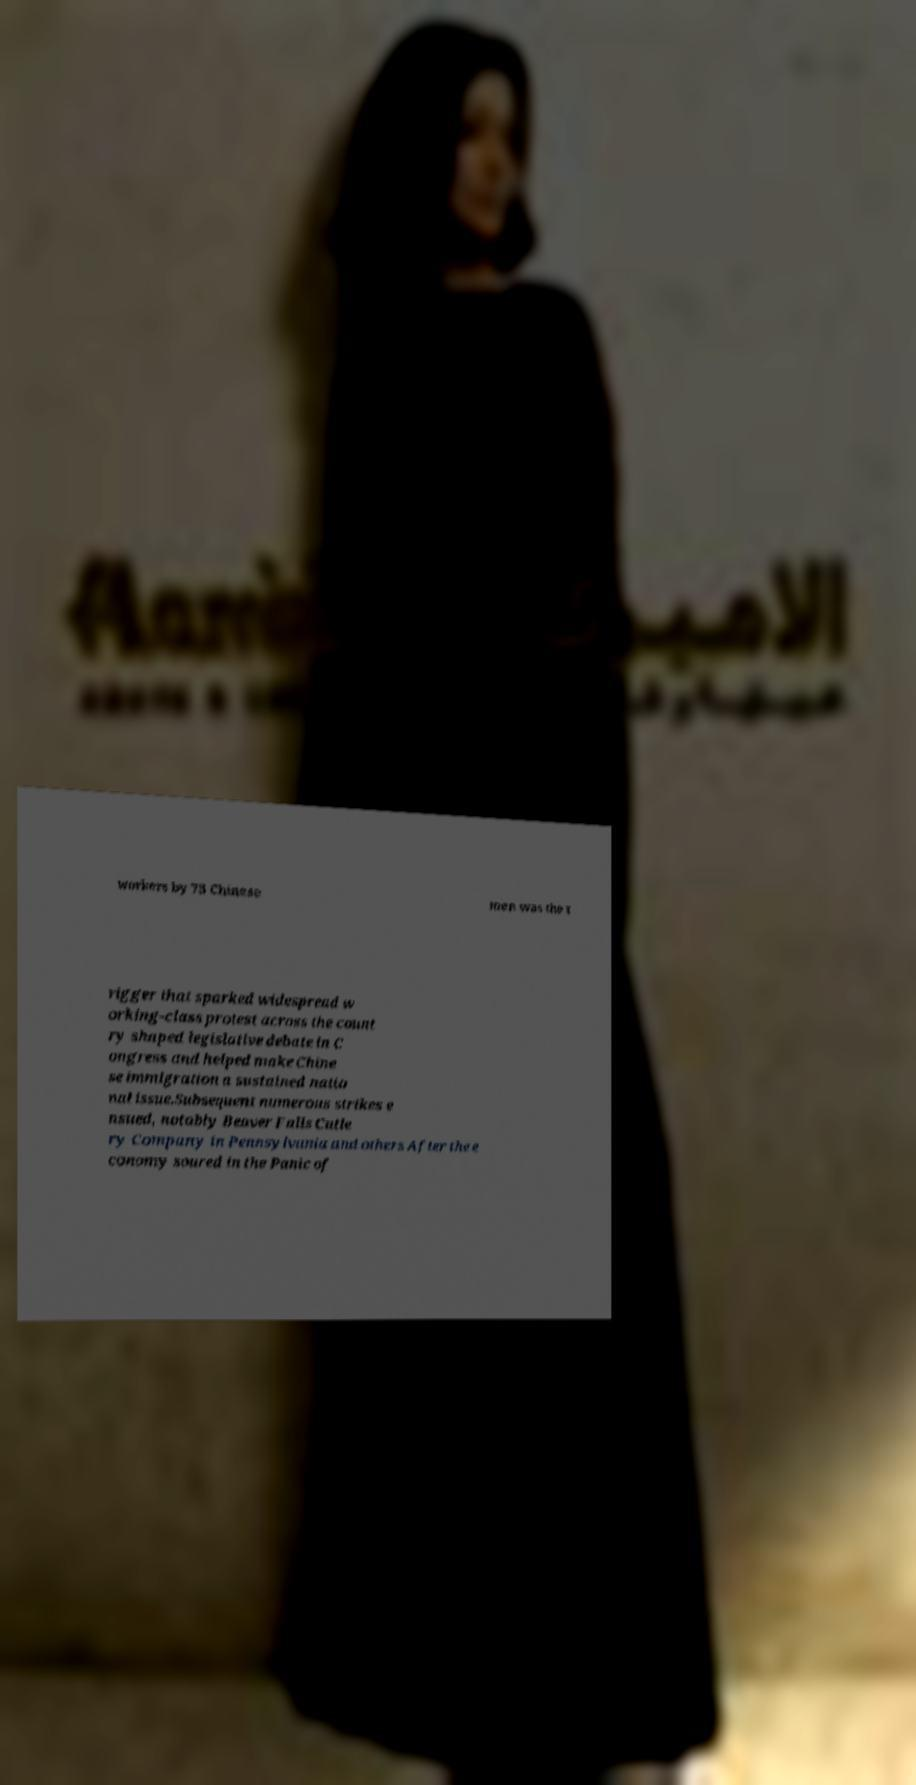I need the written content from this picture converted into text. Can you do that? workers by 75 Chinese men was the t rigger that sparked widespread w orking-class protest across the count ry shaped legislative debate in C ongress and helped make Chine se immigration a sustained natio nal issue.Subsequent numerous strikes e nsued, notably Beaver Falls Cutle ry Company in Pennsylvania and others After the e conomy soured in the Panic of 